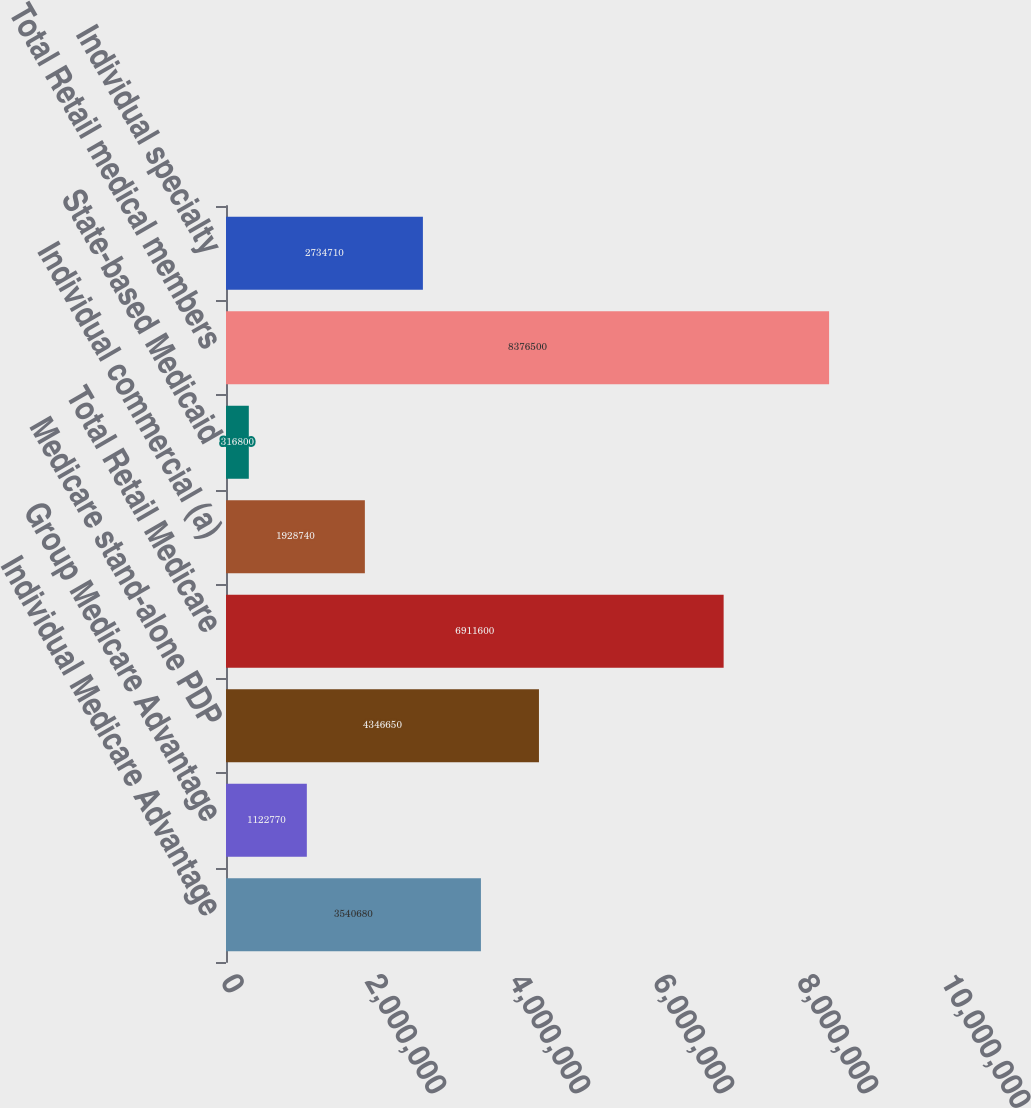<chart> <loc_0><loc_0><loc_500><loc_500><bar_chart><fcel>Individual Medicare Advantage<fcel>Group Medicare Advantage<fcel>Medicare stand-alone PDP<fcel>Total Retail Medicare<fcel>Individual commercial (a)<fcel>State-based Medicaid<fcel>Total Retail medical members<fcel>Individual specialty<nl><fcel>3.54068e+06<fcel>1.12277e+06<fcel>4.34665e+06<fcel>6.9116e+06<fcel>1.92874e+06<fcel>316800<fcel>8.3765e+06<fcel>2.73471e+06<nl></chart> 